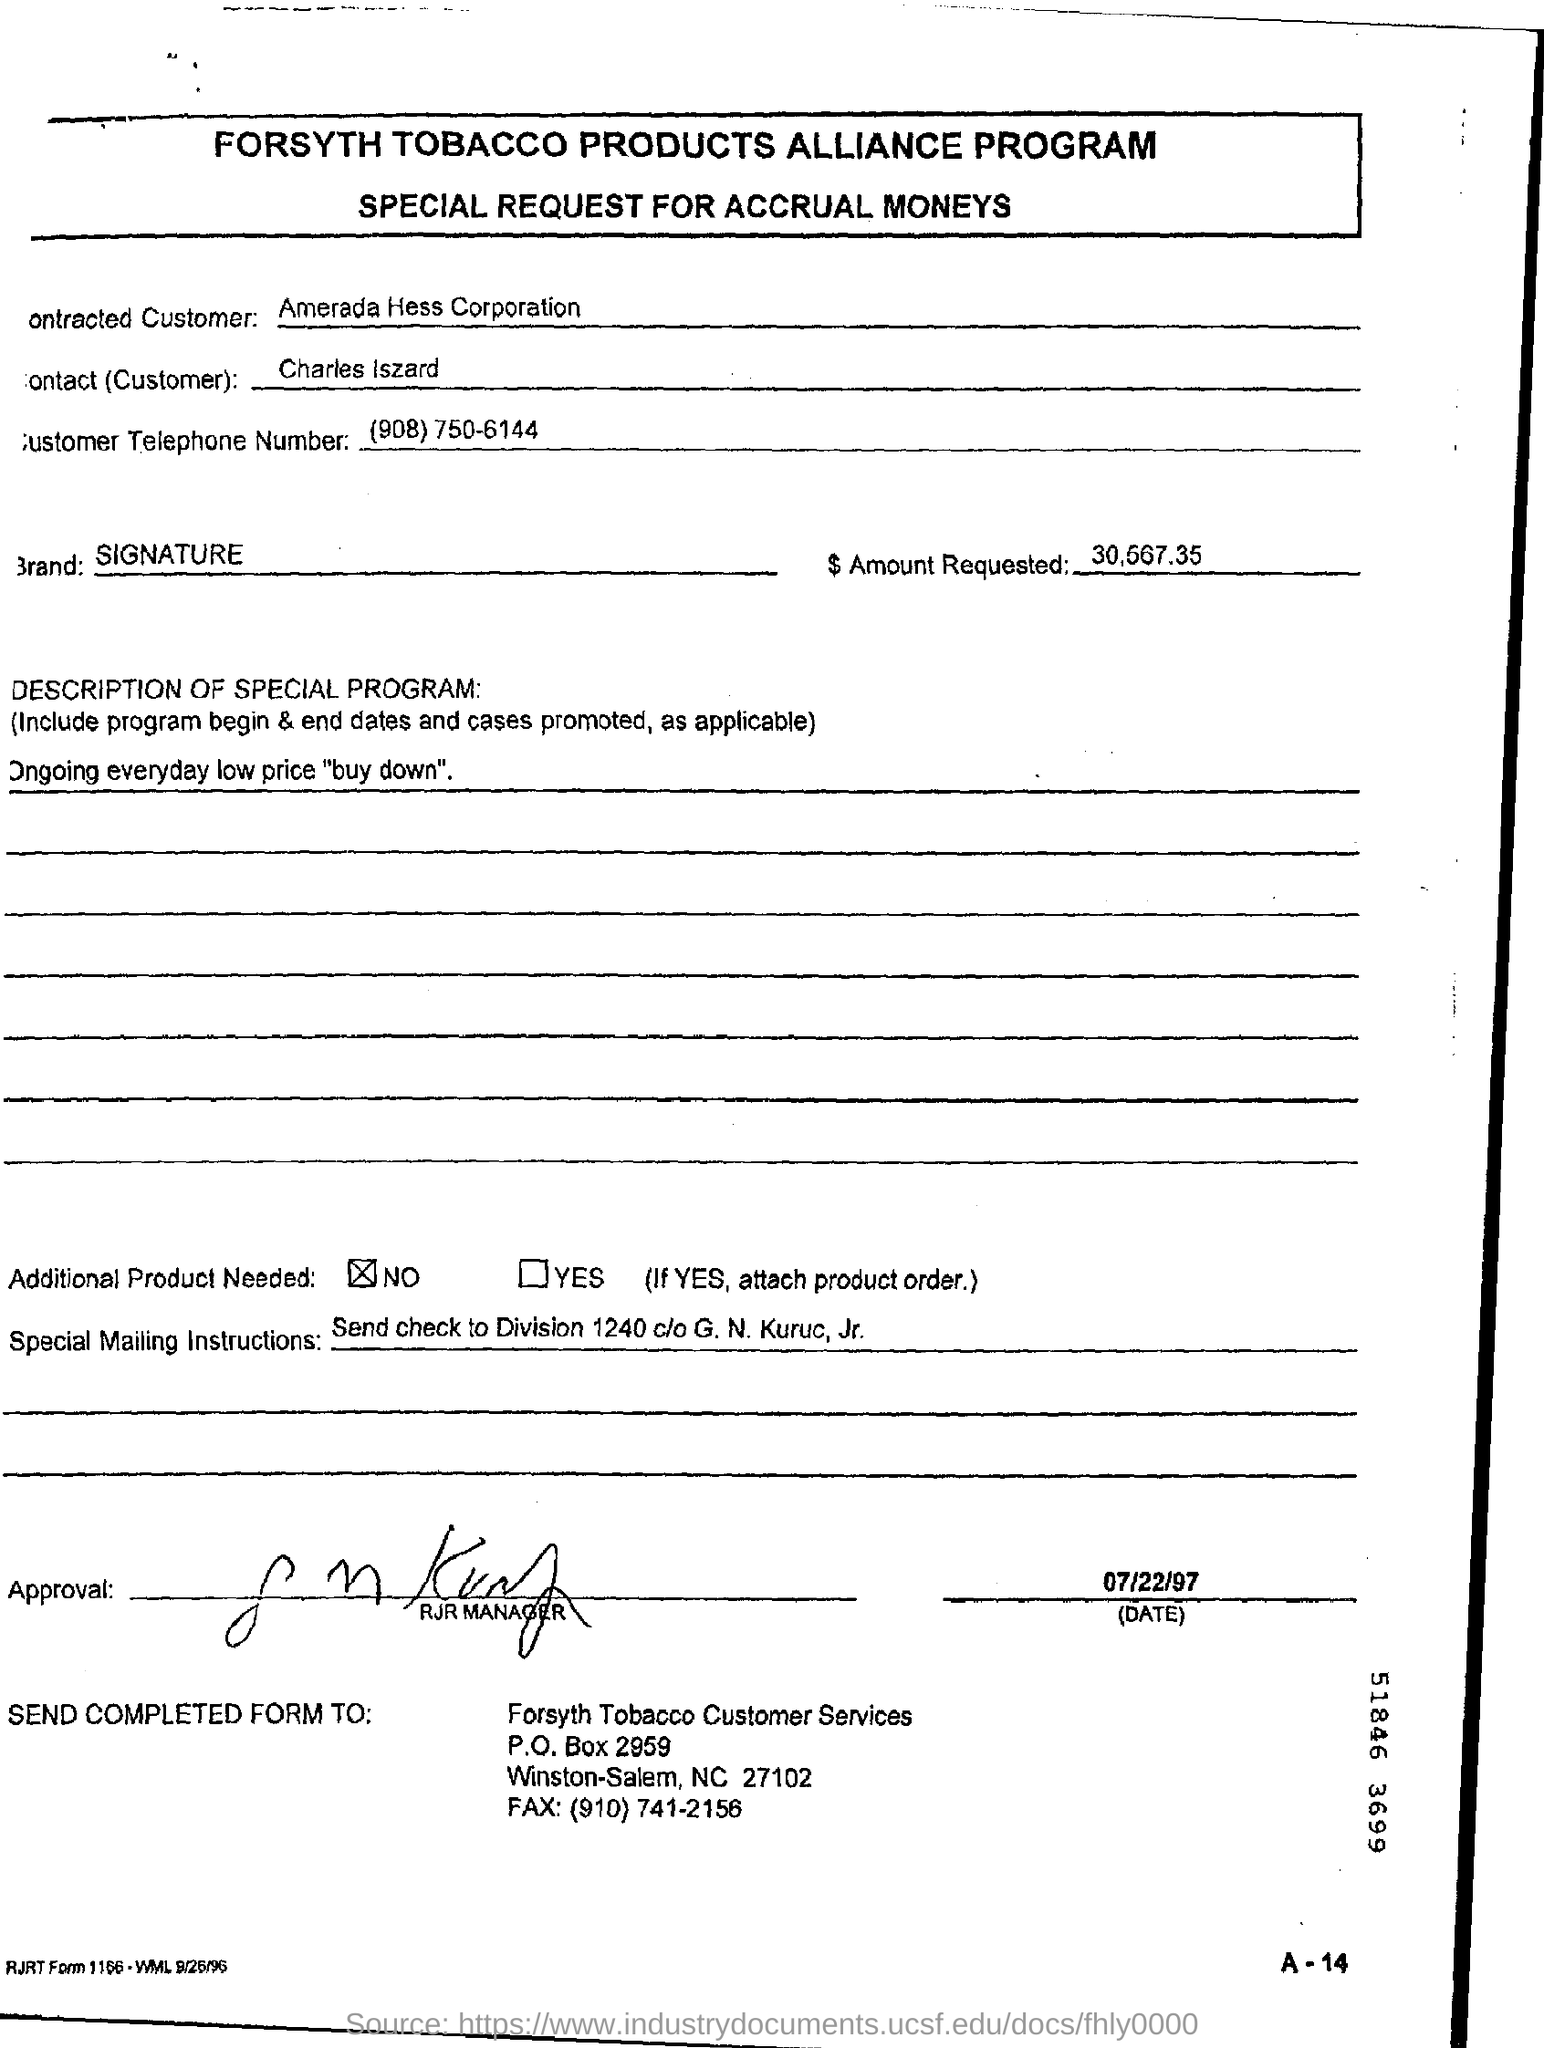Who is the Contracted Customer?
Your response must be concise. Amerada hess corporation. What is the Contact(Customer)?
Your answer should be compact. Charles Iszard. What is the Customer Telephone Number?
Give a very brief answer. (908) 750-6144. What is the Brand?
Ensure brevity in your answer.  Signature. 